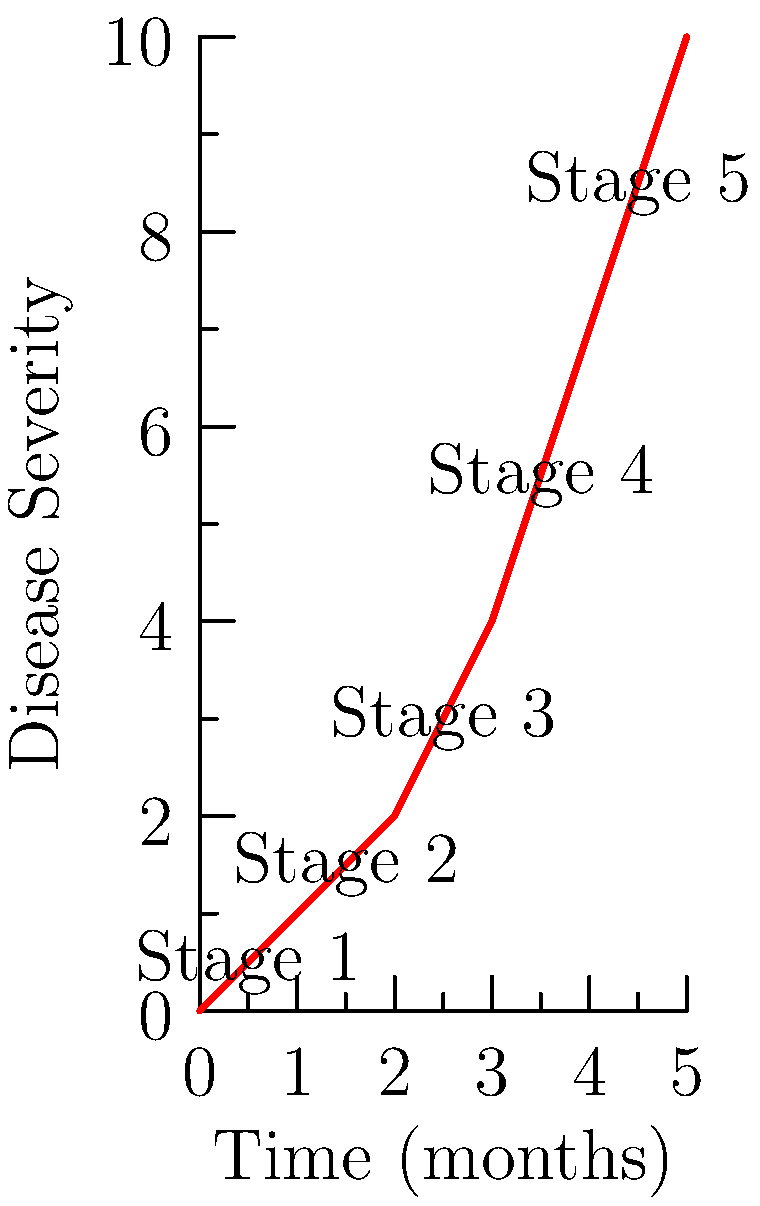Given the timeline infographic of disease progression, at which stage does the rate of increase in disease severity appear to accelerate most dramatically? To determine the stage where the rate of increase in disease severity accelerates most dramatically, we need to analyze the slope of the curve between each stage:

1. Calculate the slope between each consecutive stage:
   - Stage 1 to 2: (1.5 - 0.5) / 1 = 1
   - Stage 2 to 3: (3 - 1.5) / 1 = 1.5
   - Stage 3 to 4: (5.5 - 3) / 1 = 2.5
   - Stage 4 to 5: (8.5 - 5.5) / 1 = 3

2. Compare the differences in slopes:
   - From Stage 1-2 to 2-3: 1.5 - 1 = 0.5
   - From Stage 2-3 to 3-4: 2.5 - 1.5 = 1
   - From Stage 3-4 to 4-5: 3 - 2.5 = 0.5

3. The largest increase in slope occurs between Stages 2-3 and 3-4, with a difference of 1.

4. This indicates that the rate of increase in disease severity accelerates most dramatically at Stage 3.
Answer: Stage 3 